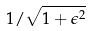<formula> <loc_0><loc_0><loc_500><loc_500>1 / \sqrt { 1 + \epsilon ^ { 2 } }</formula> 